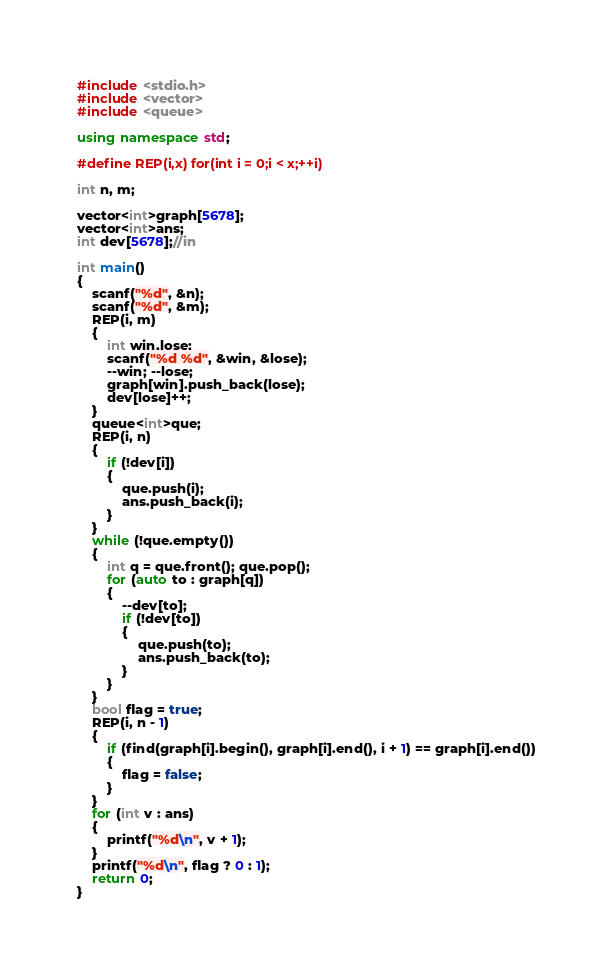Convert code to text. <code><loc_0><loc_0><loc_500><loc_500><_C++_>
#include <stdio.h>
#include <vector>
#include <queue>

using namespace std;

#define REP(i,x) for(int i = 0;i < x;++i)

int n, m;

vector<int>graph[5678];
vector<int>ans;
int dev[5678];//in

int main()
{
	scanf("%d", &n);
	scanf("%d", &m);
	REP(i, m)
	{
		int win,lose;
		scanf("%d %d", &win, &lose);
		--win; --lose;
		graph[win].push_back(lose);
		dev[lose]++;
	}
	queue<int>que;
	REP(i, n)
	{
		if (!dev[i])
		{
			que.push(i);
			ans.push_back(i);
		}
	}
	while (!que.empty())
	{
		int q = que.front(); que.pop();
		for (auto to : graph[q])
		{
			--dev[to];
			if (!dev[to])
			{
				que.push(to);
				ans.push_back(to);
			}
		}
	}
	bool flag = true;
	REP(i, n - 1)
	{
		if (find(graph[i].begin(), graph[i].end(), i + 1) == graph[i].end())
		{
			flag = false;
		}
	}
	for (int v : ans)
	{
		printf("%d\n", v + 1);
	}
	printf("%d\n", flag ? 0 : 1);
	return 0;
}</code> 